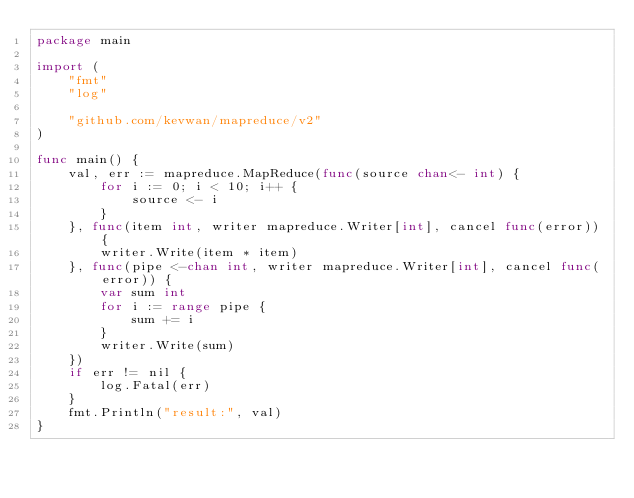<code> <loc_0><loc_0><loc_500><loc_500><_Go_>package main

import (
	"fmt"
	"log"

	"github.com/kevwan/mapreduce/v2"
)

func main() {
	val, err := mapreduce.MapReduce(func(source chan<- int) {
		for i := 0; i < 10; i++ {
			source <- i
		}
	}, func(item int, writer mapreduce.Writer[int], cancel func(error)) {
		writer.Write(item * item)
	}, func(pipe <-chan int, writer mapreduce.Writer[int], cancel func(error)) {
		var sum int
		for i := range pipe {
			sum += i
		}
		writer.Write(sum)
	})
	if err != nil {
		log.Fatal(err)
	}
	fmt.Println("result:", val)
}
</code> 